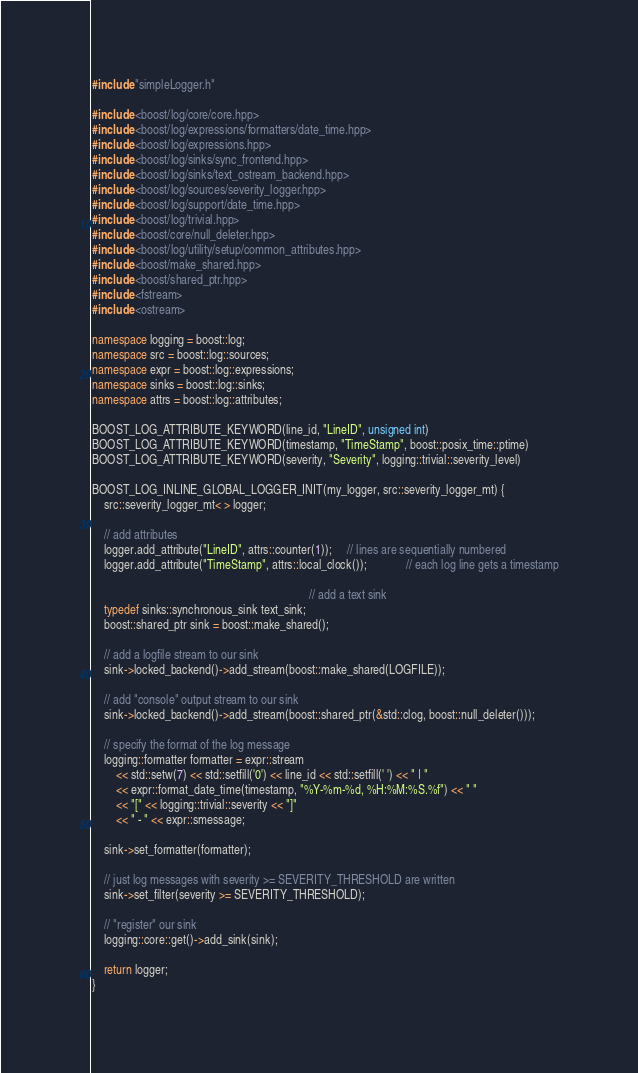<code> <loc_0><loc_0><loc_500><loc_500><_C++_>#include "simpleLogger.h"

#include <boost/log/core/core.hpp>
#include <boost/log/expressions/formatters/date_time.hpp>
#include <boost/log/expressions.hpp>
#include <boost/log/sinks/sync_frontend.hpp>
#include <boost/log/sinks/text_ostream_backend.hpp>
#include <boost/log/sources/severity_logger.hpp>
#include <boost/log/support/date_time.hpp>
#include <boost/log/trivial.hpp>
#include <boost/core/null_deleter.hpp>
#include <boost/log/utility/setup/common_attributes.hpp>
#include <boost/make_shared.hpp>
#include <boost/shared_ptr.hpp>
#include <fstream>
#include <ostream>

namespace logging = boost::log;
namespace src = boost::log::sources;
namespace expr = boost::log::expressions;
namespace sinks = boost::log::sinks;
namespace attrs = boost::log::attributes;

BOOST_LOG_ATTRIBUTE_KEYWORD(line_id, "LineID", unsigned int)
BOOST_LOG_ATTRIBUTE_KEYWORD(timestamp, "TimeStamp", boost::posix_time::ptime)
BOOST_LOG_ATTRIBUTE_KEYWORD(severity, "Severity", logging::trivial::severity_level)

BOOST_LOG_INLINE_GLOBAL_LOGGER_INIT(my_logger, src::severity_logger_mt) {
	src::severity_logger_mt< > logger;

	// add attributes
	logger.add_attribute("LineID", attrs::counter(1));     // lines are sequentially numbered
	logger.add_attribute("TimeStamp", attrs::local_clock());             // each log line gets a timestamp

																		 // add a text sink
	typedef sinks::synchronous_sink text_sink;
	boost::shared_ptr sink = boost::make_shared();

	// add a logfile stream to our sink
	sink->locked_backend()->add_stream(boost::make_shared(LOGFILE));

	// add "console" output stream to our sink
	sink->locked_backend()->add_stream(boost::shared_ptr(&std::clog, boost::null_deleter()));

	// specify the format of the log message
	logging::formatter formatter = expr::stream
		<< std::setw(7) << std::setfill('0') << line_id << std::setfill(' ') << " | "
		<< expr::format_date_time(timestamp, "%Y-%m-%d, %H:%M:%S.%f") << " "
		<< "[" << logging::trivial::severity << "]"
		<< " - " << expr::smessage;

	sink->set_formatter(formatter);

	// just log messages with severity >= SEVERITY_THRESHOLD are written
	sink->set_filter(severity >= SEVERITY_THRESHOLD);

	// "register" our sink
	logging::core::get()->add_sink(sink);

	return logger;
}
</code> 